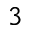Convert formula to latex. <formula><loc_0><loc_0><loc_500><loc_500>^ { 3 }</formula> 